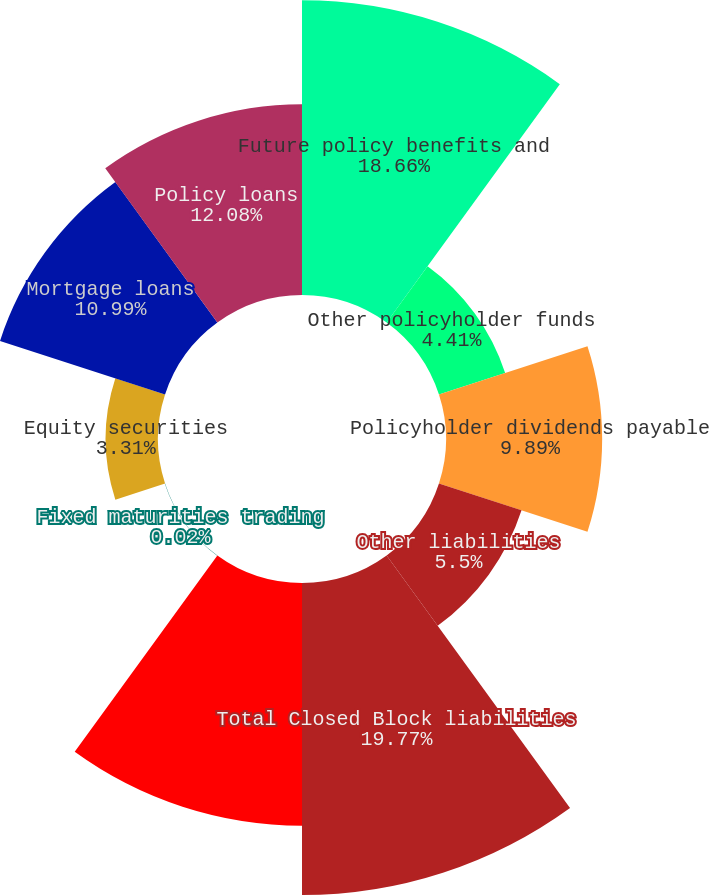<chart> <loc_0><loc_0><loc_500><loc_500><pie_chart><fcel>Future policy benefits and<fcel>Other policyholder funds<fcel>Policyholder dividends payable<fcel>Other liabilities<fcel>Total Closed Block liabilities<fcel>Fixed maturities<fcel>Fixed maturities trading<fcel>Equity securities<fcel>Mortgage loans<fcel>Policy loans<nl><fcel>18.66%<fcel>4.41%<fcel>9.89%<fcel>5.5%<fcel>19.76%<fcel>15.37%<fcel>0.02%<fcel>3.31%<fcel>10.99%<fcel>12.08%<nl></chart> 